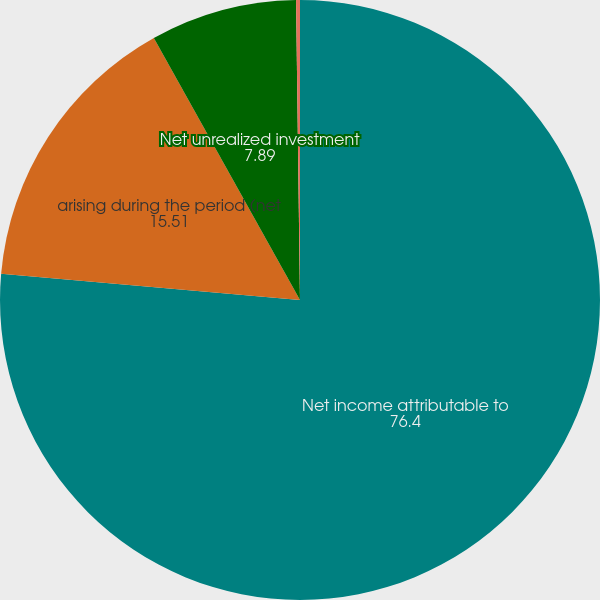Convert chart to OTSL. <chart><loc_0><loc_0><loc_500><loc_500><pie_chart><fcel>Net income attributable to<fcel>arising during the period (net<fcel>Net unrealized investment<fcel>Foreign currency translation<nl><fcel>76.4%<fcel>15.51%<fcel>7.89%<fcel>0.21%<nl></chart> 